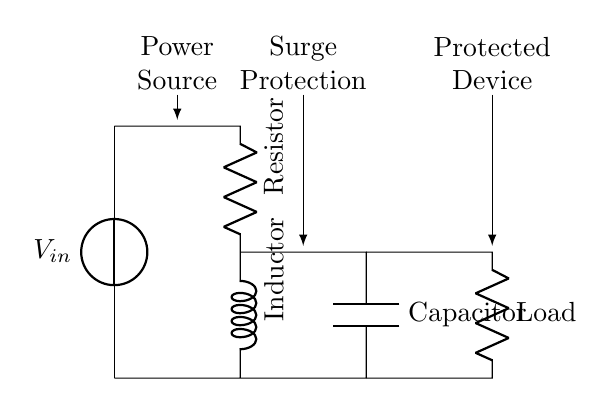What type of circuit is this? This circuit is a power conditioning circuit, which incorporates resistive, inductive, and capacitive components to protect electronic devices during voltage surges.
Answer: RLC What is the purpose of the inductor in this circuit? The inductor is used to oppose changes in current, helping to filter out surges and stabilize the current flowing to the protected device.
Answer: Surge protection How many components are directly connected in series in this circuit? In the main branch of the circuit, there are three components (resistor, inductor, and capacitor) connected in series before reaching the load.
Answer: Three What is connected at the end of the circuit after the capacitor? The load, which represents the protected device, is connected at the end of the circuit after the capacitor.
Answer: Load What role does the capacitor play in this circuit? The capacitor acts to smooth out voltage fluctuations and can provide a temporary storage of electrical charge, further protecting devices from surges.
Answer: Voltage smoothing How does the resistor affect the overall circuit functionality? The resistor limits the amount of current flowing in the circuit, thereby preventing excessive current which could damage the components and the connected devices.
Answer: Current limiting 